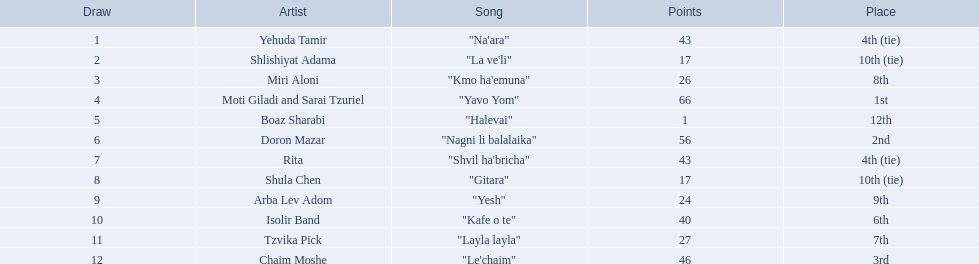Who are all the performers? Yehuda Tamir, Shlishiyat Adama, Miri Aloni, Moti Giladi and Sarai Tzuriel, Boaz Sharabi, Doron Mazar, Rita, Shula Chen, Arba Lev Adom, Isolir Band, Tzvika Pick, Chaim Moshe. How many points did each acquire? 43, 17, 26, 66, 1, 56, 43, 17, 24, 40, 27, 46. And which performer had the lowest amount of points? Boaz Sharabi. What are the scores? 43, 17, 26, 66, 1, 56, 43, 17, 24, 40, 27, 46. Who has the lowest? 1. Which artist possesses that amount? Boaz Sharabi. Who are the artists in question? Yehuda Tamir, Shlishiyat Adama, Miri Aloni, Moti Giladi and Sarai Tzuriel, Boaz Sharabi, Doron Mazar, Rita, Shula Chen, Arba Lev Adom, Isolir Band, Tzvika Pick, Chaim Moshe. What were their individual scores? 43, 17, 26, 66, 1, 56, 43, 17, 24, 40, 27, 46. And which artist had the minimum points? Boaz Sharabi. 